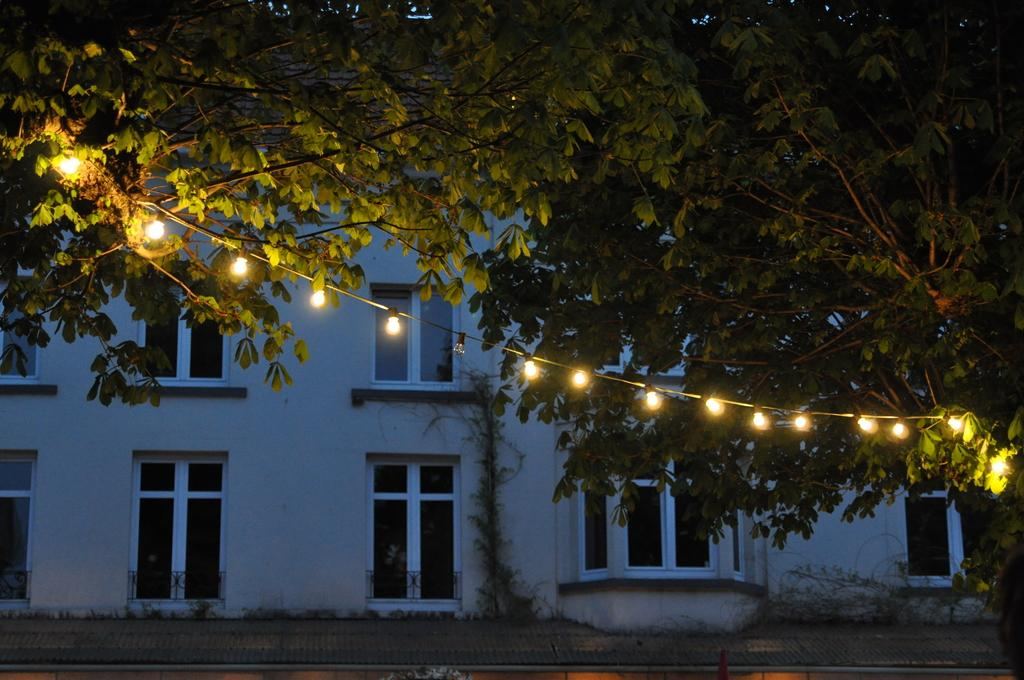What is the main object in the image? There is a tree in the image. What is unique about the tree? Lights are attached to the tree. What type of building can be seen in the image? There is a building with glass windows in the image. What type of spark can be seen coming from the shoe in the image? There is no shoe present in the image, so there cannot be any spark coming from it. 